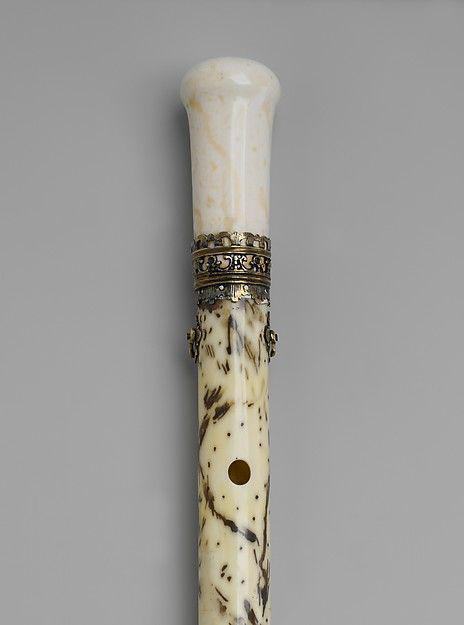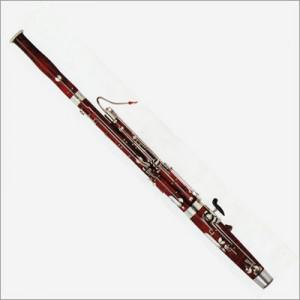The first image is the image on the left, the second image is the image on the right. Considering the images on both sides, is "The instrument on the left has several rings going around its body." valid? Answer yes or no. No. The first image is the image on the left, the second image is the image on the right. Analyze the images presented: Is the assertion "There is a single  brown wooden flute standing up with one hole for the month and seven hole at the bottom for the fingers to cover." valid? Answer yes or no. No. 